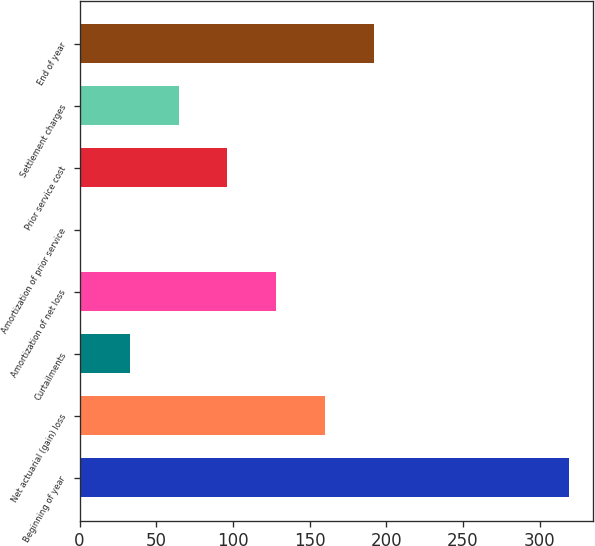Convert chart to OTSL. <chart><loc_0><loc_0><loc_500><loc_500><bar_chart><fcel>Beginning of year<fcel>Net actuarial (gain) loss<fcel>Curtailments<fcel>Amortization of net loss<fcel>Amortization of prior service<fcel>Prior service cost<fcel>Settlement charges<fcel>End of year<nl><fcel>319<fcel>160<fcel>32.8<fcel>128.2<fcel>1<fcel>96.4<fcel>64.6<fcel>191.8<nl></chart> 